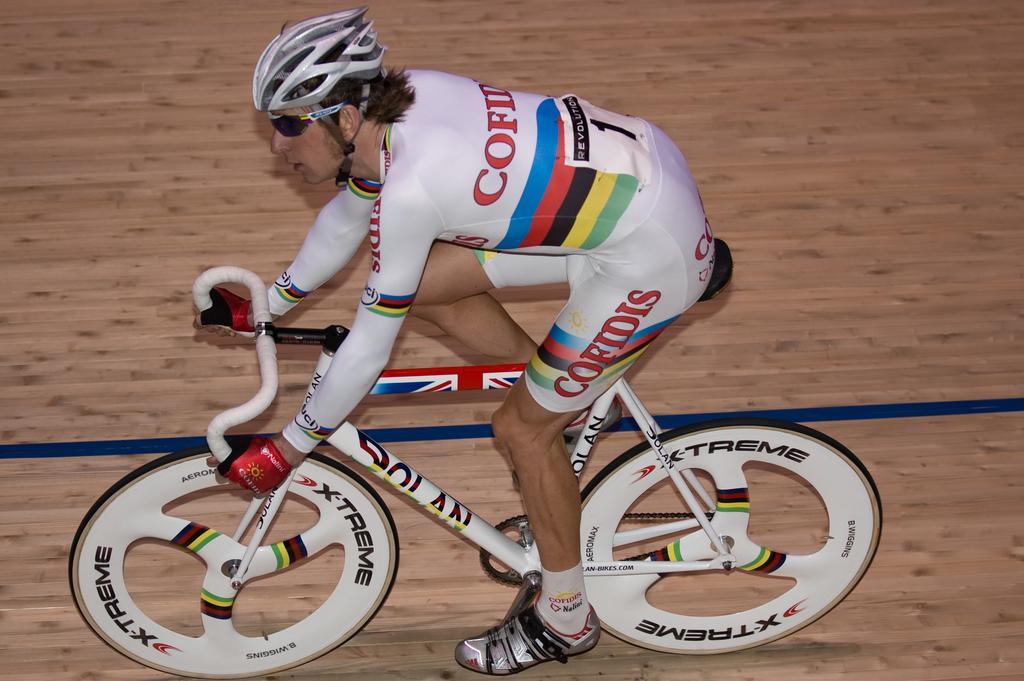Describe this image in one or two sentences. In the middle of the image a man is riding on the bicycle. At the bottom of the image there is a floor. 